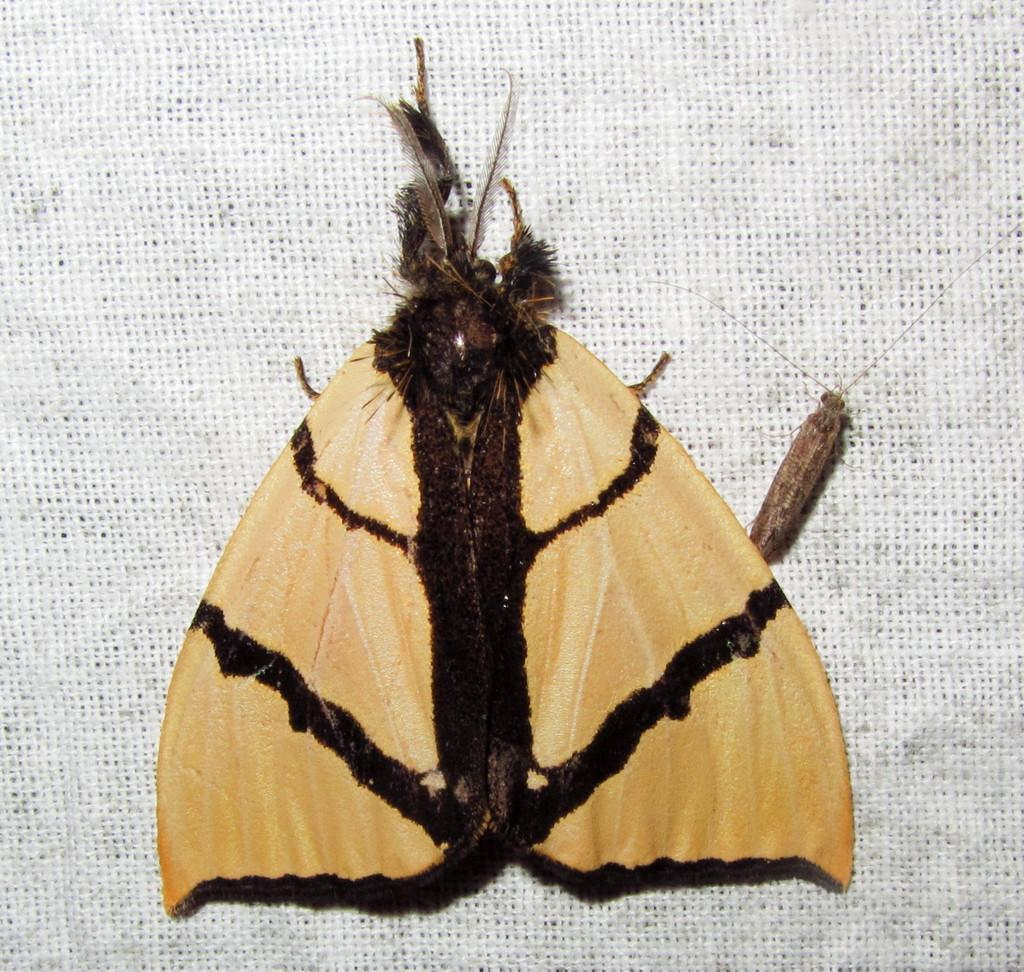What type of creature can be seen in the image? There is an insect in the image. What is the insect resting on or near in the image? The insect is on a white-colored object. How many sisters are present in the image? There are no sisters present in the image, as it only features an insect on a white-colored object. 